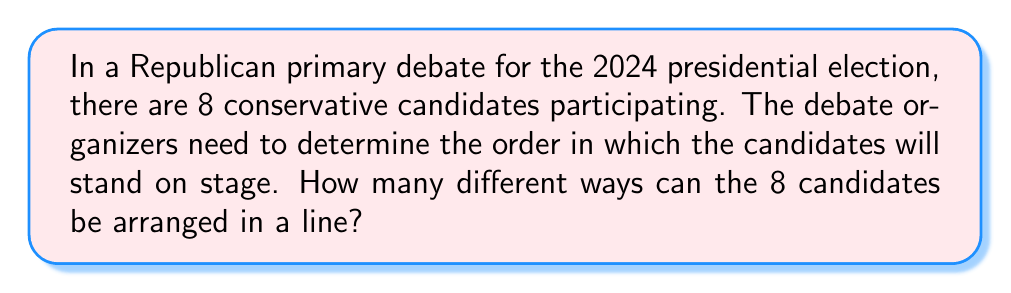Give your solution to this math problem. To solve this problem, we need to use the concept of permutations. A permutation is an arrangement of objects in a specific order, where each object is used exactly once.

In this case, we have 8 candidates, and we want to arrange all of them in a line. This is a straightforward permutation problem because:

1. All 8 candidates must be used.
2. The order matters (different arrangements are considered distinct).
3. Each candidate can only be used once.

The formula for permutations of n distinct objects is:

$$ P(n) = n! $$

Where $n!$ represents the factorial of n, which is the product of all positive integers less than or equal to n.

For our problem, $n = 8$, so we calculate:

$$ P(8) = 8! = 8 \times 7 \times 6 \times 5 \times 4 \times 3 \times 2 \times 1 = 40,320 $$

This calculation can be interpreted as follows:
- For the first position, we have 8 choices.
- For the second position, we have 7 remaining choices.
- For the third position, we have 6 remaining choices.
- And so on, until we place the last candidate.

The product of these numbers gives us the total number of possible arrangements.

As a conservative journalism student at Texas State University, understanding these permutations could be useful for reporting on debate preparations or analyzing the potential impact of candidate positioning during televised events.
Answer: $40,320$ different ways 